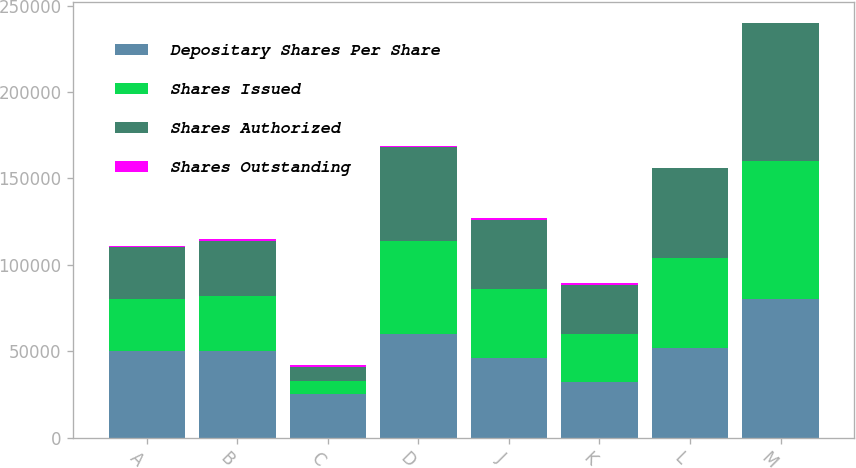Convert chart. <chart><loc_0><loc_0><loc_500><loc_500><stacked_bar_chart><ecel><fcel>A<fcel>B<fcel>C<fcel>D<fcel>J<fcel>K<fcel>L<fcel>M<nl><fcel>Depositary Shares Per Share<fcel>50000<fcel>50000<fcel>25000<fcel>60000<fcel>46000<fcel>32200<fcel>52000<fcel>80000<nl><fcel>Shares Issued<fcel>30000<fcel>32000<fcel>8000<fcel>54000<fcel>40000<fcel>28000<fcel>52000<fcel>80000<nl><fcel>Shares Authorized<fcel>29999<fcel>32000<fcel>8000<fcel>53999<fcel>40000<fcel>28000<fcel>52000<fcel>80000<nl><fcel>Shares Outstanding<fcel>1000<fcel>1000<fcel>1000<fcel>1000<fcel>1000<fcel>1000<fcel>25<fcel>25<nl></chart> 